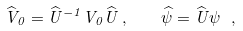Convert formula to latex. <formula><loc_0><loc_0><loc_500><loc_500>\widehat { V } _ { 0 } = \widehat { U } ^ { - 1 } V _ { 0 } \widehat { U } \, , \quad \widehat { \psi } = \widehat { U } \psi \ ,</formula> 